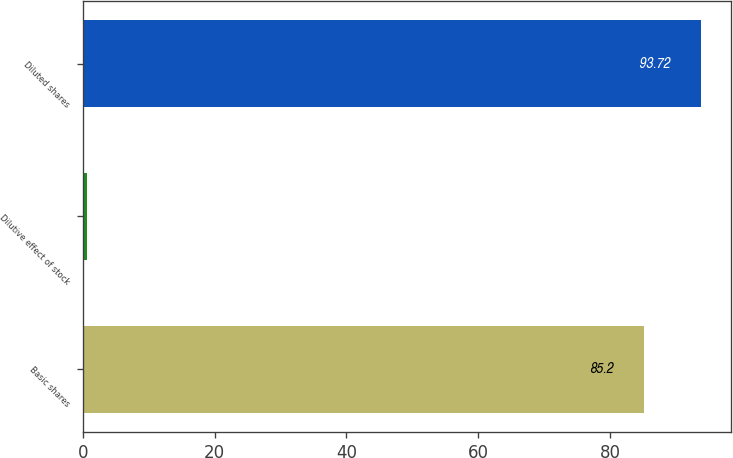<chart> <loc_0><loc_0><loc_500><loc_500><bar_chart><fcel>Basic shares<fcel>Dilutive effect of stock<fcel>Diluted shares<nl><fcel>85.2<fcel>0.7<fcel>93.72<nl></chart> 